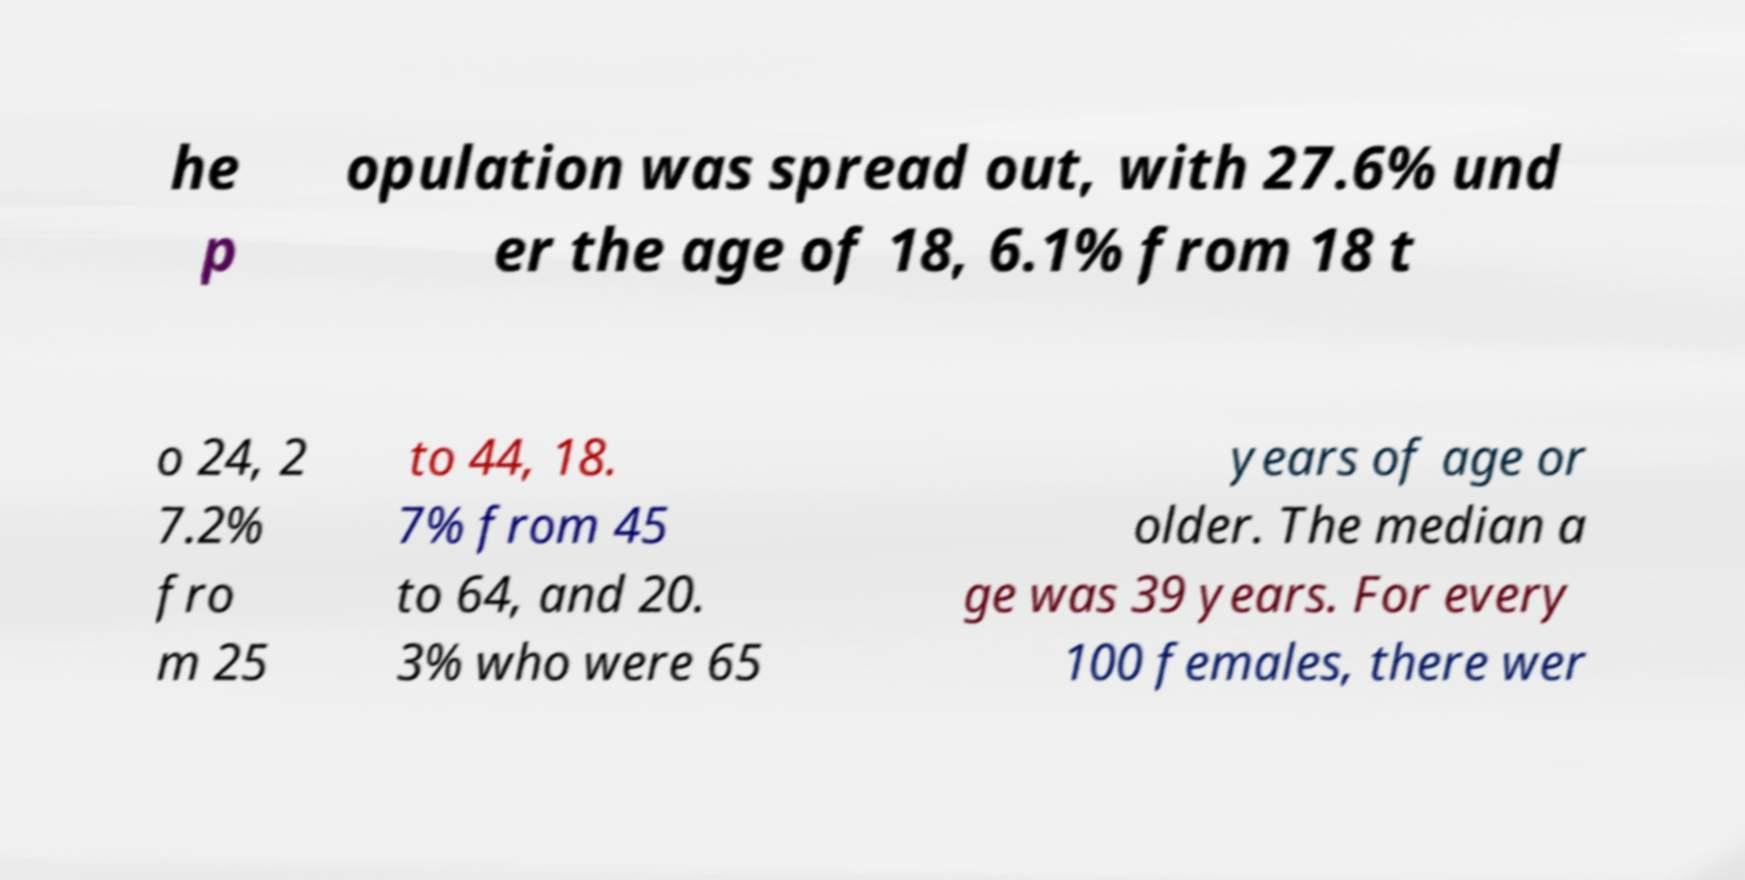Could you extract and type out the text from this image? he p opulation was spread out, with 27.6% und er the age of 18, 6.1% from 18 t o 24, 2 7.2% fro m 25 to 44, 18. 7% from 45 to 64, and 20. 3% who were 65 years of age or older. The median a ge was 39 years. For every 100 females, there wer 